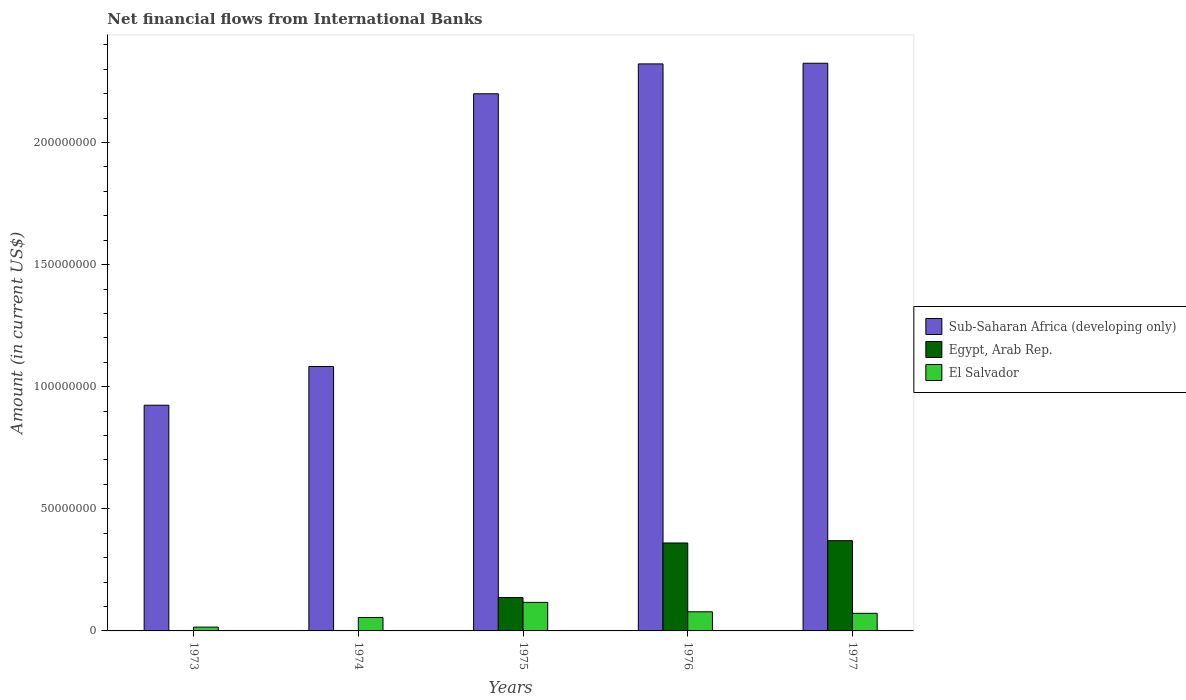How many different coloured bars are there?
Make the answer very short. 3. Are the number of bars on each tick of the X-axis equal?
Your response must be concise. No. How many bars are there on the 3rd tick from the left?
Offer a very short reply. 3. How many bars are there on the 2nd tick from the right?
Give a very brief answer. 3. What is the label of the 1st group of bars from the left?
Your answer should be very brief. 1973. What is the net financial aid flows in Egypt, Arab Rep. in 1977?
Offer a very short reply. 3.69e+07. Across all years, what is the maximum net financial aid flows in El Salvador?
Offer a very short reply. 1.17e+07. Across all years, what is the minimum net financial aid flows in Sub-Saharan Africa (developing only)?
Your answer should be very brief. 9.24e+07. In which year was the net financial aid flows in Sub-Saharan Africa (developing only) maximum?
Ensure brevity in your answer.  1977. What is the total net financial aid flows in El Salvador in the graph?
Provide a succinct answer. 3.38e+07. What is the difference between the net financial aid flows in Sub-Saharan Africa (developing only) in 1974 and that in 1977?
Give a very brief answer. -1.24e+08. What is the difference between the net financial aid flows in Egypt, Arab Rep. in 1975 and the net financial aid flows in Sub-Saharan Africa (developing only) in 1974?
Your answer should be very brief. -9.46e+07. What is the average net financial aid flows in Sub-Saharan Africa (developing only) per year?
Give a very brief answer. 1.77e+08. In the year 1976, what is the difference between the net financial aid flows in Sub-Saharan Africa (developing only) and net financial aid flows in Egypt, Arab Rep.?
Provide a short and direct response. 1.96e+08. In how many years, is the net financial aid flows in Sub-Saharan Africa (developing only) greater than 80000000 US$?
Your answer should be very brief. 5. What is the ratio of the net financial aid flows in Sub-Saharan Africa (developing only) in 1973 to that in 1977?
Ensure brevity in your answer.  0.4. Is the net financial aid flows in Sub-Saharan Africa (developing only) in 1973 less than that in 1974?
Offer a very short reply. Yes. What is the difference between the highest and the second highest net financial aid flows in Sub-Saharan Africa (developing only)?
Give a very brief answer. 2.63e+05. What is the difference between the highest and the lowest net financial aid flows in Sub-Saharan Africa (developing only)?
Ensure brevity in your answer.  1.40e+08. In how many years, is the net financial aid flows in El Salvador greater than the average net financial aid flows in El Salvador taken over all years?
Give a very brief answer. 3. Is the sum of the net financial aid flows in El Salvador in 1973 and 1976 greater than the maximum net financial aid flows in Sub-Saharan Africa (developing only) across all years?
Make the answer very short. No. Are all the bars in the graph horizontal?
Make the answer very short. No. How many years are there in the graph?
Make the answer very short. 5. What is the difference between two consecutive major ticks on the Y-axis?
Provide a succinct answer. 5.00e+07. Where does the legend appear in the graph?
Provide a succinct answer. Center right. How are the legend labels stacked?
Keep it short and to the point. Vertical. What is the title of the graph?
Offer a very short reply. Net financial flows from International Banks. What is the Amount (in current US$) of Sub-Saharan Africa (developing only) in 1973?
Offer a terse response. 9.24e+07. What is the Amount (in current US$) in Egypt, Arab Rep. in 1973?
Offer a very short reply. 0. What is the Amount (in current US$) of El Salvador in 1973?
Offer a very short reply. 1.56e+06. What is the Amount (in current US$) of Sub-Saharan Africa (developing only) in 1974?
Your response must be concise. 1.08e+08. What is the Amount (in current US$) of El Salvador in 1974?
Offer a very short reply. 5.51e+06. What is the Amount (in current US$) in Sub-Saharan Africa (developing only) in 1975?
Ensure brevity in your answer.  2.20e+08. What is the Amount (in current US$) in Egypt, Arab Rep. in 1975?
Make the answer very short. 1.37e+07. What is the Amount (in current US$) in El Salvador in 1975?
Ensure brevity in your answer.  1.17e+07. What is the Amount (in current US$) in Sub-Saharan Africa (developing only) in 1976?
Offer a terse response. 2.32e+08. What is the Amount (in current US$) of Egypt, Arab Rep. in 1976?
Your answer should be very brief. 3.60e+07. What is the Amount (in current US$) in El Salvador in 1976?
Your answer should be compact. 7.83e+06. What is the Amount (in current US$) of Sub-Saharan Africa (developing only) in 1977?
Ensure brevity in your answer.  2.32e+08. What is the Amount (in current US$) of Egypt, Arab Rep. in 1977?
Your response must be concise. 3.69e+07. What is the Amount (in current US$) of El Salvador in 1977?
Offer a very short reply. 7.20e+06. Across all years, what is the maximum Amount (in current US$) in Sub-Saharan Africa (developing only)?
Keep it short and to the point. 2.32e+08. Across all years, what is the maximum Amount (in current US$) in Egypt, Arab Rep.?
Your answer should be very brief. 3.69e+07. Across all years, what is the maximum Amount (in current US$) of El Salvador?
Offer a terse response. 1.17e+07. Across all years, what is the minimum Amount (in current US$) in Sub-Saharan Africa (developing only)?
Offer a very short reply. 9.24e+07. Across all years, what is the minimum Amount (in current US$) in El Salvador?
Keep it short and to the point. 1.56e+06. What is the total Amount (in current US$) in Sub-Saharan Africa (developing only) in the graph?
Keep it short and to the point. 8.85e+08. What is the total Amount (in current US$) of Egypt, Arab Rep. in the graph?
Provide a succinct answer. 8.66e+07. What is the total Amount (in current US$) of El Salvador in the graph?
Offer a very short reply. 3.38e+07. What is the difference between the Amount (in current US$) in Sub-Saharan Africa (developing only) in 1973 and that in 1974?
Ensure brevity in your answer.  -1.58e+07. What is the difference between the Amount (in current US$) of El Salvador in 1973 and that in 1974?
Provide a short and direct response. -3.95e+06. What is the difference between the Amount (in current US$) of Sub-Saharan Africa (developing only) in 1973 and that in 1975?
Keep it short and to the point. -1.28e+08. What is the difference between the Amount (in current US$) in El Salvador in 1973 and that in 1975?
Ensure brevity in your answer.  -1.01e+07. What is the difference between the Amount (in current US$) in Sub-Saharan Africa (developing only) in 1973 and that in 1976?
Give a very brief answer. -1.40e+08. What is the difference between the Amount (in current US$) in El Salvador in 1973 and that in 1976?
Keep it short and to the point. -6.28e+06. What is the difference between the Amount (in current US$) of Sub-Saharan Africa (developing only) in 1973 and that in 1977?
Keep it short and to the point. -1.40e+08. What is the difference between the Amount (in current US$) of El Salvador in 1973 and that in 1977?
Keep it short and to the point. -5.65e+06. What is the difference between the Amount (in current US$) in Sub-Saharan Africa (developing only) in 1974 and that in 1975?
Give a very brief answer. -1.12e+08. What is the difference between the Amount (in current US$) of El Salvador in 1974 and that in 1975?
Give a very brief answer. -6.18e+06. What is the difference between the Amount (in current US$) of Sub-Saharan Africa (developing only) in 1974 and that in 1976?
Your answer should be compact. -1.24e+08. What is the difference between the Amount (in current US$) in El Salvador in 1974 and that in 1976?
Give a very brief answer. -2.33e+06. What is the difference between the Amount (in current US$) in Sub-Saharan Africa (developing only) in 1974 and that in 1977?
Provide a short and direct response. -1.24e+08. What is the difference between the Amount (in current US$) in El Salvador in 1974 and that in 1977?
Offer a very short reply. -1.70e+06. What is the difference between the Amount (in current US$) in Sub-Saharan Africa (developing only) in 1975 and that in 1976?
Provide a succinct answer. -1.22e+07. What is the difference between the Amount (in current US$) in Egypt, Arab Rep. in 1975 and that in 1976?
Your answer should be very brief. -2.23e+07. What is the difference between the Amount (in current US$) in El Salvador in 1975 and that in 1976?
Give a very brief answer. 3.86e+06. What is the difference between the Amount (in current US$) of Sub-Saharan Africa (developing only) in 1975 and that in 1977?
Your response must be concise. -1.25e+07. What is the difference between the Amount (in current US$) in Egypt, Arab Rep. in 1975 and that in 1977?
Provide a short and direct response. -2.33e+07. What is the difference between the Amount (in current US$) of El Salvador in 1975 and that in 1977?
Give a very brief answer. 4.49e+06. What is the difference between the Amount (in current US$) in Sub-Saharan Africa (developing only) in 1976 and that in 1977?
Keep it short and to the point. -2.63e+05. What is the difference between the Amount (in current US$) of Egypt, Arab Rep. in 1976 and that in 1977?
Provide a short and direct response. -9.43e+05. What is the difference between the Amount (in current US$) of El Salvador in 1976 and that in 1977?
Keep it short and to the point. 6.29e+05. What is the difference between the Amount (in current US$) of Sub-Saharan Africa (developing only) in 1973 and the Amount (in current US$) of El Salvador in 1974?
Give a very brief answer. 8.69e+07. What is the difference between the Amount (in current US$) of Sub-Saharan Africa (developing only) in 1973 and the Amount (in current US$) of Egypt, Arab Rep. in 1975?
Provide a succinct answer. 7.88e+07. What is the difference between the Amount (in current US$) in Sub-Saharan Africa (developing only) in 1973 and the Amount (in current US$) in El Salvador in 1975?
Give a very brief answer. 8.07e+07. What is the difference between the Amount (in current US$) in Sub-Saharan Africa (developing only) in 1973 and the Amount (in current US$) in Egypt, Arab Rep. in 1976?
Ensure brevity in your answer.  5.64e+07. What is the difference between the Amount (in current US$) of Sub-Saharan Africa (developing only) in 1973 and the Amount (in current US$) of El Salvador in 1976?
Provide a short and direct response. 8.46e+07. What is the difference between the Amount (in current US$) of Sub-Saharan Africa (developing only) in 1973 and the Amount (in current US$) of Egypt, Arab Rep. in 1977?
Your answer should be compact. 5.55e+07. What is the difference between the Amount (in current US$) in Sub-Saharan Africa (developing only) in 1973 and the Amount (in current US$) in El Salvador in 1977?
Give a very brief answer. 8.52e+07. What is the difference between the Amount (in current US$) of Sub-Saharan Africa (developing only) in 1974 and the Amount (in current US$) of Egypt, Arab Rep. in 1975?
Your response must be concise. 9.46e+07. What is the difference between the Amount (in current US$) in Sub-Saharan Africa (developing only) in 1974 and the Amount (in current US$) in El Salvador in 1975?
Provide a short and direct response. 9.66e+07. What is the difference between the Amount (in current US$) in Sub-Saharan Africa (developing only) in 1974 and the Amount (in current US$) in Egypt, Arab Rep. in 1976?
Provide a succinct answer. 7.23e+07. What is the difference between the Amount (in current US$) of Sub-Saharan Africa (developing only) in 1974 and the Amount (in current US$) of El Salvador in 1976?
Offer a terse response. 1.00e+08. What is the difference between the Amount (in current US$) in Sub-Saharan Africa (developing only) in 1974 and the Amount (in current US$) in Egypt, Arab Rep. in 1977?
Your answer should be compact. 7.13e+07. What is the difference between the Amount (in current US$) in Sub-Saharan Africa (developing only) in 1974 and the Amount (in current US$) in El Salvador in 1977?
Offer a terse response. 1.01e+08. What is the difference between the Amount (in current US$) of Sub-Saharan Africa (developing only) in 1975 and the Amount (in current US$) of Egypt, Arab Rep. in 1976?
Your answer should be compact. 1.84e+08. What is the difference between the Amount (in current US$) in Sub-Saharan Africa (developing only) in 1975 and the Amount (in current US$) in El Salvador in 1976?
Ensure brevity in your answer.  2.12e+08. What is the difference between the Amount (in current US$) of Egypt, Arab Rep. in 1975 and the Amount (in current US$) of El Salvador in 1976?
Ensure brevity in your answer.  5.84e+06. What is the difference between the Amount (in current US$) in Sub-Saharan Africa (developing only) in 1975 and the Amount (in current US$) in Egypt, Arab Rep. in 1977?
Your answer should be compact. 1.83e+08. What is the difference between the Amount (in current US$) in Sub-Saharan Africa (developing only) in 1975 and the Amount (in current US$) in El Salvador in 1977?
Give a very brief answer. 2.13e+08. What is the difference between the Amount (in current US$) in Egypt, Arab Rep. in 1975 and the Amount (in current US$) in El Salvador in 1977?
Offer a terse response. 6.46e+06. What is the difference between the Amount (in current US$) of Sub-Saharan Africa (developing only) in 1976 and the Amount (in current US$) of Egypt, Arab Rep. in 1977?
Offer a very short reply. 1.95e+08. What is the difference between the Amount (in current US$) of Sub-Saharan Africa (developing only) in 1976 and the Amount (in current US$) of El Salvador in 1977?
Keep it short and to the point. 2.25e+08. What is the difference between the Amount (in current US$) in Egypt, Arab Rep. in 1976 and the Amount (in current US$) in El Salvador in 1977?
Ensure brevity in your answer.  2.88e+07. What is the average Amount (in current US$) of Sub-Saharan Africa (developing only) per year?
Your answer should be very brief. 1.77e+08. What is the average Amount (in current US$) in Egypt, Arab Rep. per year?
Provide a short and direct response. 1.73e+07. What is the average Amount (in current US$) in El Salvador per year?
Your answer should be compact. 6.76e+06. In the year 1973, what is the difference between the Amount (in current US$) of Sub-Saharan Africa (developing only) and Amount (in current US$) of El Salvador?
Ensure brevity in your answer.  9.09e+07. In the year 1974, what is the difference between the Amount (in current US$) of Sub-Saharan Africa (developing only) and Amount (in current US$) of El Salvador?
Your answer should be compact. 1.03e+08. In the year 1975, what is the difference between the Amount (in current US$) of Sub-Saharan Africa (developing only) and Amount (in current US$) of Egypt, Arab Rep.?
Your answer should be very brief. 2.06e+08. In the year 1975, what is the difference between the Amount (in current US$) in Sub-Saharan Africa (developing only) and Amount (in current US$) in El Salvador?
Ensure brevity in your answer.  2.08e+08. In the year 1975, what is the difference between the Amount (in current US$) of Egypt, Arab Rep. and Amount (in current US$) of El Salvador?
Offer a very short reply. 1.98e+06. In the year 1976, what is the difference between the Amount (in current US$) in Sub-Saharan Africa (developing only) and Amount (in current US$) in Egypt, Arab Rep.?
Offer a terse response. 1.96e+08. In the year 1976, what is the difference between the Amount (in current US$) of Sub-Saharan Africa (developing only) and Amount (in current US$) of El Salvador?
Your response must be concise. 2.24e+08. In the year 1976, what is the difference between the Amount (in current US$) of Egypt, Arab Rep. and Amount (in current US$) of El Salvador?
Give a very brief answer. 2.82e+07. In the year 1977, what is the difference between the Amount (in current US$) in Sub-Saharan Africa (developing only) and Amount (in current US$) in Egypt, Arab Rep.?
Keep it short and to the point. 1.96e+08. In the year 1977, what is the difference between the Amount (in current US$) of Sub-Saharan Africa (developing only) and Amount (in current US$) of El Salvador?
Make the answer very short. 2.25e+08. In the year 1977, what is the difference between the Amount (in current US$) of Egypt, Arab Rep. and Amount (in current US$) of El Salvador?
Provide a short and direct response. 2.97e+07. What is the ratio of the Amount (in current US$) of Sub-Saharan Africa (developing only) in 1973 to that in 1974?
Make the answer very short. 0.85. What is the ratio of the Amount (in current US$) in El Salvador in 1973 to that in 1974?
Your answer should be compact. 0.28. What is the ratio of the Amount (in current US$) in Sub-Saharan Africa (developing only) in 1973 to that in 1975?
Your response must be concise. 0.42. What is the ratio of the Amount (in current US$) of El Salvador in 1973 to that in 1975?
Keep it short and to the point. 0.13. What is the ratio of the Amount (in current US$) in Sub-Saharan Africa (developing only) in 1973 to that in 1976?
Ensure brevity in your answer.  0.4. What is the ratio of the Amount (in current US$) of El Salvador in 1973 to that in 1976?
Give a very brief answer. 0.2. What is the ratio of the Amount (in current US$) of Sub-Saharan Africa (developing only) in 1973 to that in 1977?
Keep it short and to the point. 0.4. What is the ratio of the Amount (in current US$) of El Salvador in 1973 to that in 1977?
Your answer should be very brief. 0.22. What is the ratio of the Amount (in current US$) in Sub-Saharan Africa (developing only) in 1974 to that in 1975?
Ensure brevity in your answer.  0.49. What is the ratio of the Amount (in current US$) in El Salvador in 1974 to that in 1975?
Give a very brief answer. 0.47. What is the ratio of the Amount (in current US$) in Sub-Saharan Africa (developing only) in 1974 to that in 1976?
Offer a very short reply. 0.47. What is the ratio of the Amount (in current US$) of El Salvador in 1974 to that in 1976?
Offer a terse response. 0.7. What is the ratio of the Amount (in current US$) of Sub-Saharan Africa (developing only) in 1974 to that in 1977?
Keep it short and to the point. 0.47. What is the ratio of the Amount (in current US$) in El Salvador in 1974 to that in 1977?
Ensure brevity in your answer.  0.76. What is the ratio of the Amount (in current US$) of Sub-Saharan Africa (developing only) in 1975 to that in 1976?
Provide a succinct answer. 0.95. What is the ratio of the Amount (in current US$) in Egypt, Arab Rep. in 1975 to that in 1976?
Provide a short and direct response. 0.38. What is the ratio of the Amount (in current US$) in El Salvador in 1975 to that in 1976?
Offer a terse response. 1.49. What is the ratio of the Amount (in current US$) of Sub-Saharan Africa (developing only) in 1975 to that in 1977?
Offer a terse response. 0.95. What is the ratio of the Amount (in current US$) of Egypt, Arab Rep. in 1975 to that in 1977?
Make the answer very short. 0.37. What is the ratio of the Amount (in current US$) of El Salvador in 1975 to that in 1977?
Your answer should be compact. 1.62. What is the ratio of the Amount (in current US$) in Sub-Saharan Africa (developing only) in 1976 to that in 1977?
Make the answer very short. 1. What is the ratio of the Amount (in current US$) in Egypt, Arab Rep. in 1976 to that in 1977?
Make the answer very short. 0.97. What is the ratio of the Amount (in current US$) of El Salvador in 1976 to that in 1977?
Offer a very short reply. 1.09. What is the difference between the highest and the second highest Amount (in current US$) in Sub-Saharan Africa (developing only)?
Offer a very short reply. 2.63e+05. What is the difference between the highest and the second highest Amount (in current US$) in Egypt, Arab Rep.?
Provide a succinct answer. 9.43e+05. What is the difference between the highest and the second highest Amount (in current US$) in El Salvador?
Your answer should be very brief. 3.86e+06. What is the difference between the highest and the lowest Amount (in current US$) in Sub-Saharan Africa (developing only)?
Give a very brief answer. 1.40e+08. What is the difference between the highest and the lowest Amount (in current US$) of Egypt, Arab Rep.?
Provide a succinct answer. 3.69e+07. What is the difference between the highest and the lowest Amount (in current US$) of El Salvador?
Offer a terse response. 1.01e+07. 